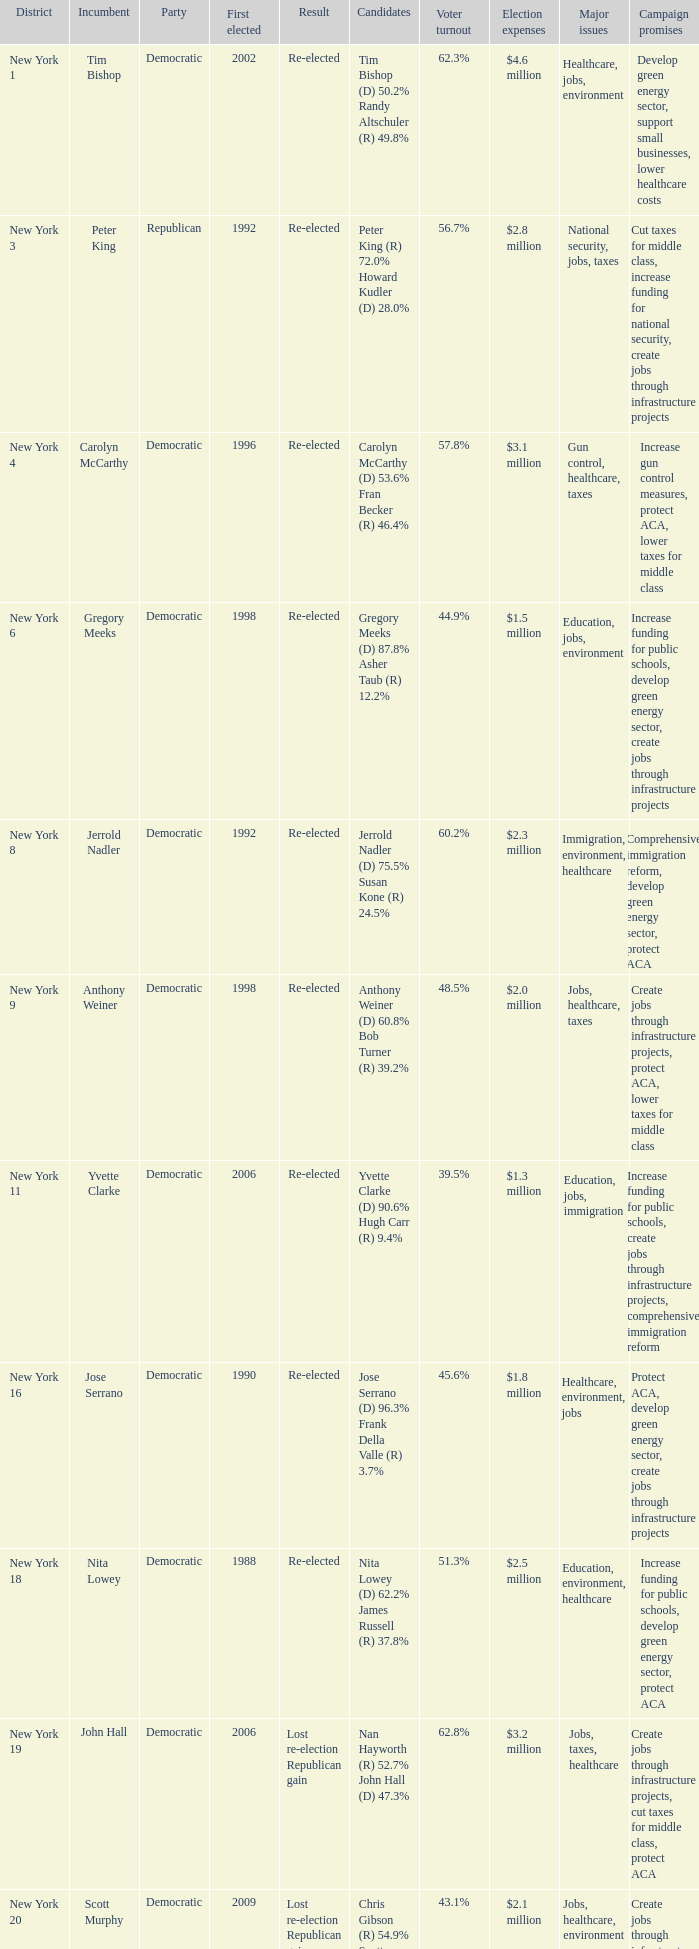Name the first elected for re-elected and brian higgins 2004.0. 